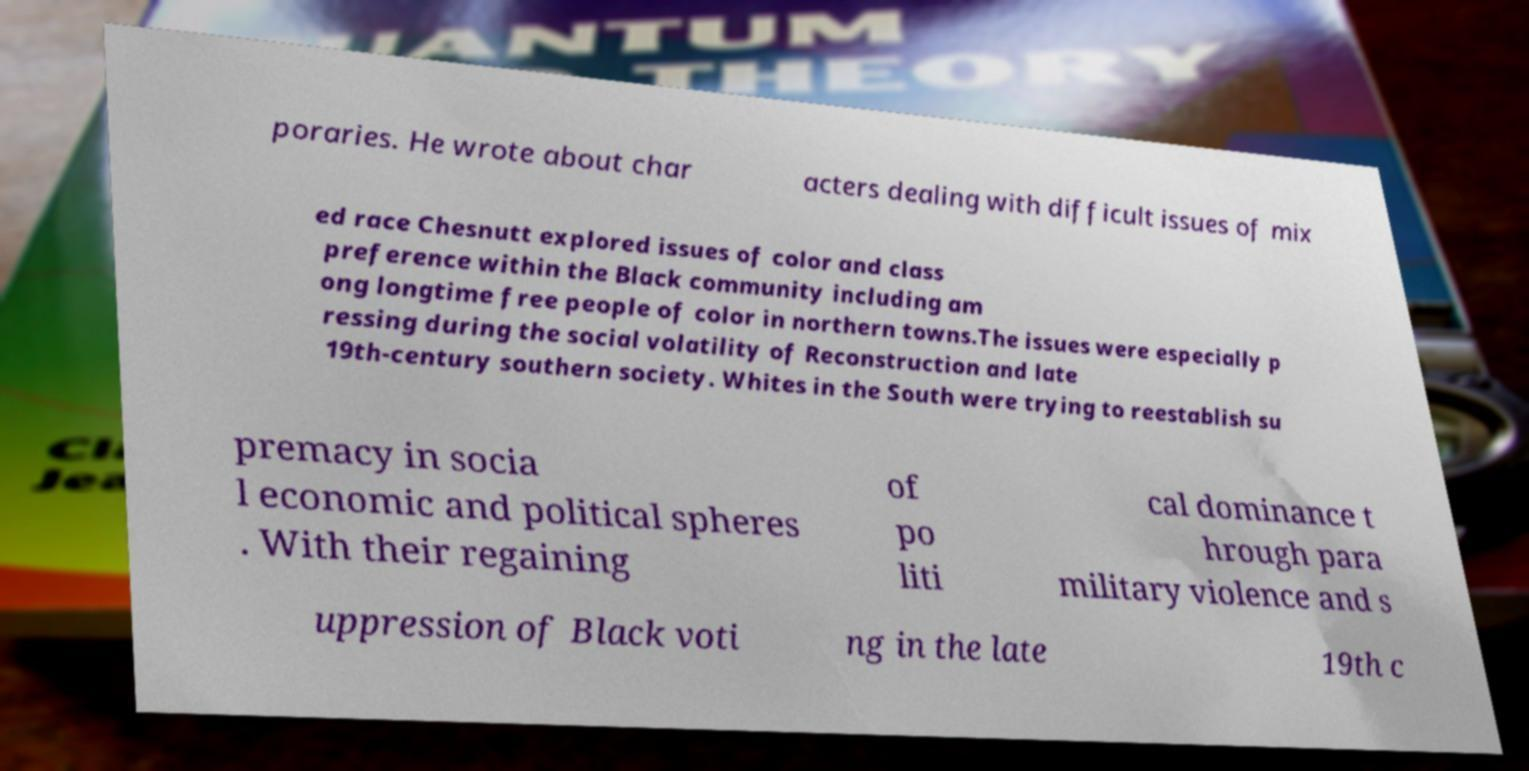Can you accurately transcribe the text from the provided image for me? poraries. He wrote about char acters dealing with difficult issues of mix ed race Chesnutt explored issues of color and class preference within the Black community including am ong longtime free people of color in northern towns.The issues were especially p ressing during the social volatility of Reconstruction and late 19th-century southern society. Whites in the South were trying to reestablish su premacy in socia l economic and political spheres . With their regaining of po liti cal dominance t hrough para military violence and s uppression of Black voti ng in the late 19th c 